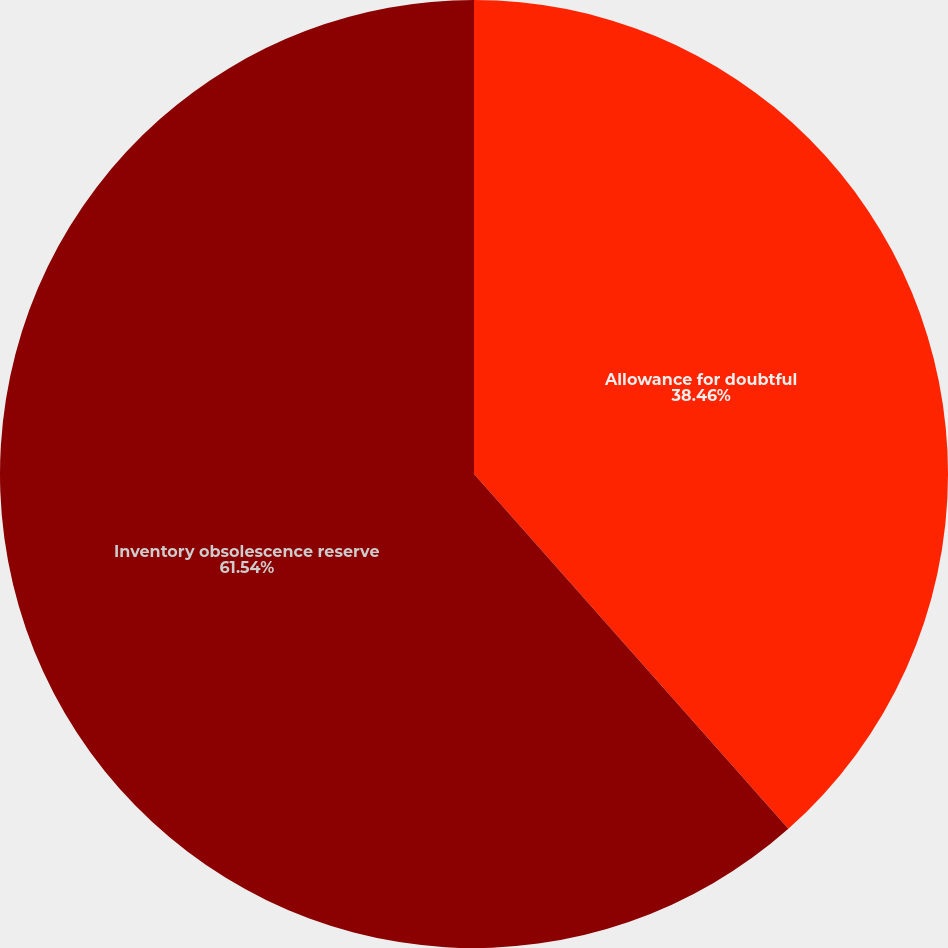Convert chart to OTSL. <chart><loc_0><loc_0><loc_500><loc_500><pie_chart><fcel>Allowance for doubtful<fcel>Inventory obsolescence reserve<nl><fcel>38.46%<fcel>61.54%<nl></chart> 